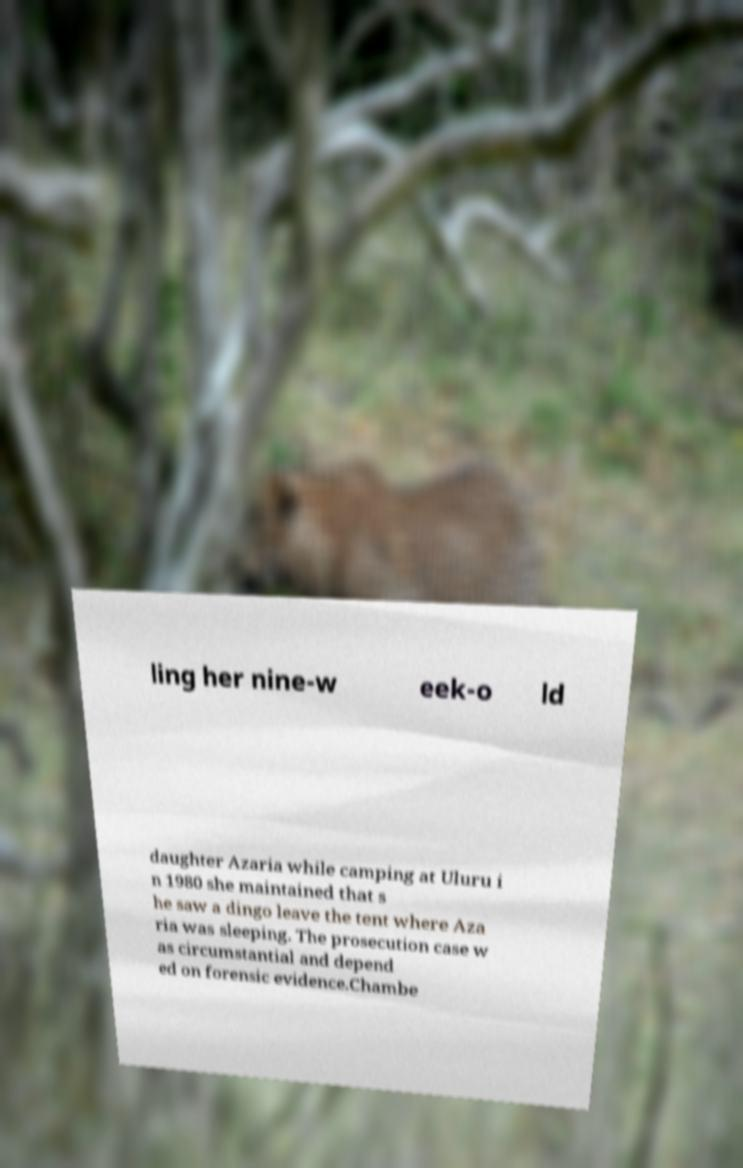There's text embedded in this image that I need extracted. Can you transcribe it verbatim? ling her nine-w eek-o ld daughter Azaria while camping at Uluru i n 1980 she maintained that s he saw a dingo leave the tent where Aza ria was sleeping. The prosecution case w as circumstantial and depend ed on forensic evidence.Chambe 